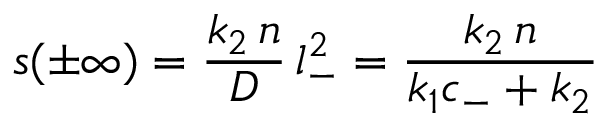Convert formula to latex. <formula><loc_0><loc_0><loc_500><loc_500>s ( \pm \infty ) = \frac { k _ { 2 } \, n } { D } \, l _ { - } ^ { 2 } = \frac { k _ { 2 } \, n } { k _ { 1 } c _ { - } + k _ { 2 } }</formula> 